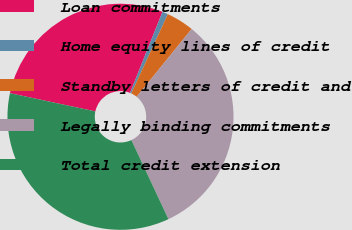<chart> <loc_0><loc_0><loc_500><loc_500><pie_chart><fcel>Loan commitments<fcel>Home equity lines of credit<fcel>Standby letters of credit and<fcel>Legally binding commitments<fcel>Total credit extension<nl><fcel>27.71%<fcel>0.82%<fcel>3.96%<fcel>32.19%<fcel>35.32%<nl></chart> 